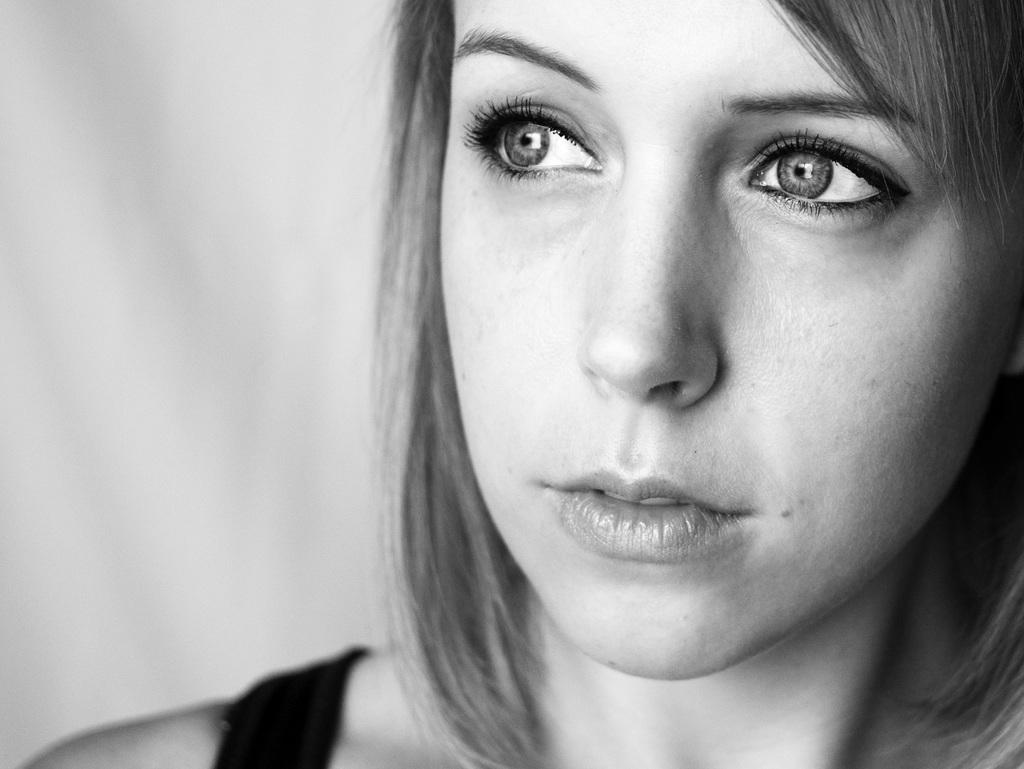What is the color scheme of the image? The image is black and white. Can you describe the main subject in the image? There is a woman in the image. What can be observed about the background of the image? The background of the image is blurred. What type of cord is being used by the woman in the image? There is no cord visible in the image. Can you describe the woman's partner in the image? There is no partner present in the image; it only features a woman. 